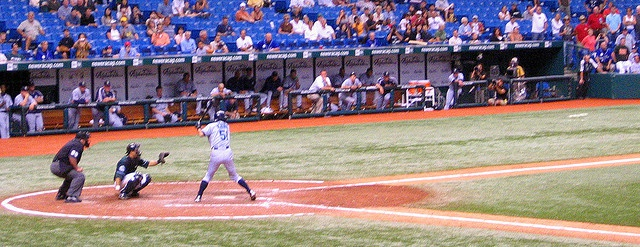Describe the objects in this image and their specific colors. I can see people in blue, black, navy, and purple tones, bench in blue, maroon, brown, and black tones, people in blue, lavender, violet, and navy tones, people in blue, black, lavender, navy, and gray tones, and people in blue, lavender, lightpink, purple, and brown tones in this image. 